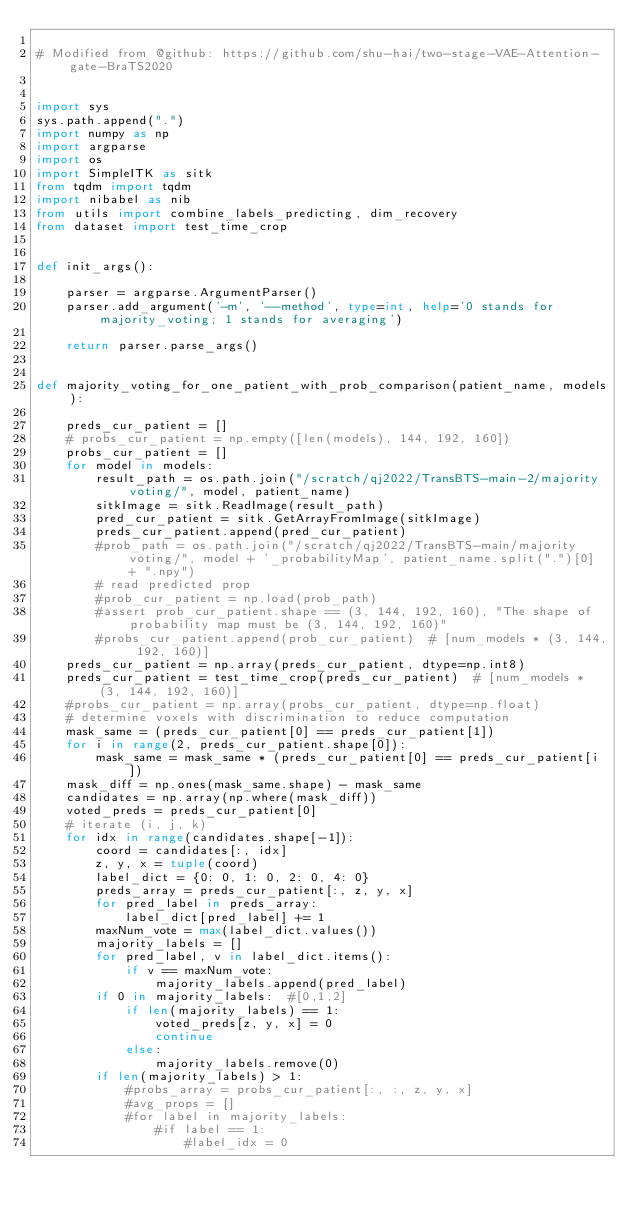<code> <loc_0><loc_0><loc_500><loc_500><_Python_>
# Modified from @github: https://github.com/shu-hai/two-stage-VAE-Attention-gate-BraTS2020


import sys
sys.path.append(".")
import numpy as np
import argparse
import os
import SimpleITK as sitk
from tqdm import tqdm
import nibabel as nib
from utils import combine_labels_predicting, dim_recovery
from dataset import test_time_crop


def init_args():

    parser = argparse.ArgumentParser()
    parser.add_argument('-m', '--method', type=int, help='0 stands for majority_voting; 1 stands for averaging')

    return parser.parse_args()


def majority_voting_for_one_patient_with_prob_comparison(patient_name, models):

    preds_cur_patient = []
    # probs_cur_patient = np.empty([len(models), 144, 192, 160])
    probs_cur_patient = []
    for model in models:
        result_path = os.path.join("/scratch/qj2022/TransBTS-main-2/majority voting/", model, patient_name)
        sitkImage = sitk.ReadImage(result_path)
        pred_cur_patient = sitk.GetArrayFromImage(sitkImage)
        preds_cur_patient.append(pred_cur_patient)
        #prob_path = os.path.join("/scratch/qj2022/TransBTS-main/majority voting/", model + '_probabilityMap', patient_name.split(".")[0] + ".npy")
        # read predicted prop
        #prob_cur_patient = np.load(prob_path)
        #assert prob_cur_patient.shape == (3, 144, 192, 160), "The shape of probability map must be (3, 144, 192, 160)"
        #probs_cur_patient.append(prob_cur_patient)  # [num_models * (3, 144, 192, 160)]
    preds_cur_patient = np.array(preds_cur_patient, dtype=np.int8)
    preds_cur_patient = test_time_crop(preds_cur_patient)  # [num_models * (3, 144, 192, 160)]
    #probs_cur_patient = np.array(probs_cur_patient, dtype=np.float)
    # determine voxels with discrimination to reduce computation
    mask_same = (preds_cur_patient[0] == preds_cur_patient[1])
    for i in range(2, preds_cur_patient.shape[0]):
        mask_same = mask_same * (preds_cur_patient[0] == preds_cur_patient[i])
    mask_diff = np.ones(mask_same.shape) - mask_same
    candidates = np.array(np.where(mask_diff))
    voted_preds = preds_cur_patient[0]
    # iterate (i, j, k)
    for idx in range(candidates.shape[-1]):
        coord = candidates[:, idx]
        z, y, x = tuple(coord)
        label_dict = {0: 0, 1: 0, 2: 0, 4: 0}
        preds_array = preds_cur_patient[:, z, y, x]
        for pred_label in preds_array:
            label_dict[pred_label] += 1
        maxNum_vote = max(label_dict.values())
        majority_labels = []
        for pred_label, v in label_dict.items():
            if v == maxNum_vote:
                majority_labels.append(pred_label)
        if 0 in majority_labels:  #[0,1,2]
            if len(majority_labels) == 1:
                voted_preds[z, y, x] = 0
                continue
            else:
                majority_labels.remove(0)
        if len(majority_labels) > 1:
            #probs_array = probs_cur_patient[:, :, z, y, x]
            #avg_props = []
            #for label in majority_labels:
                #if label == 1:
                    #label_idx = 0</code> 